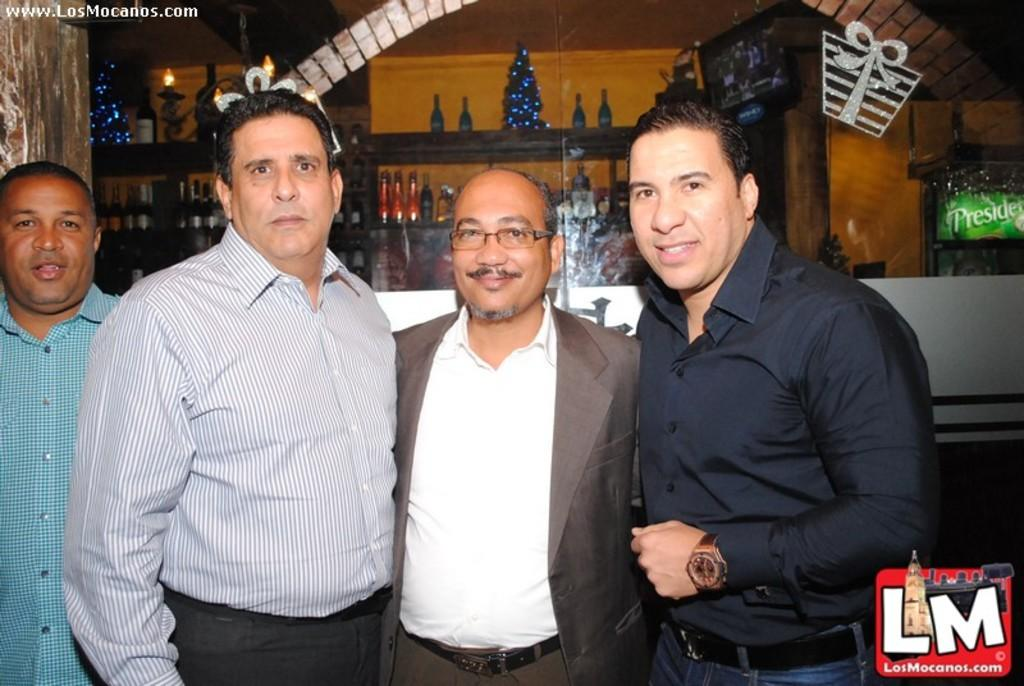How many men are present in the image? There are four men standing in the image. What type of door can be seen in the image? There is a glass door in the image. What is placed in the rack? Bottles and decorative items are placed in the rack. Are there any visible imperfections on the image? Yes, there are watermarks on the image. How many eggs are visible on the rack in the image? There are no eggs visible on the rack in the image. Can you see a ladybug crawling on the glass door in the image? There is no ladybug present on the glass door in the image. 